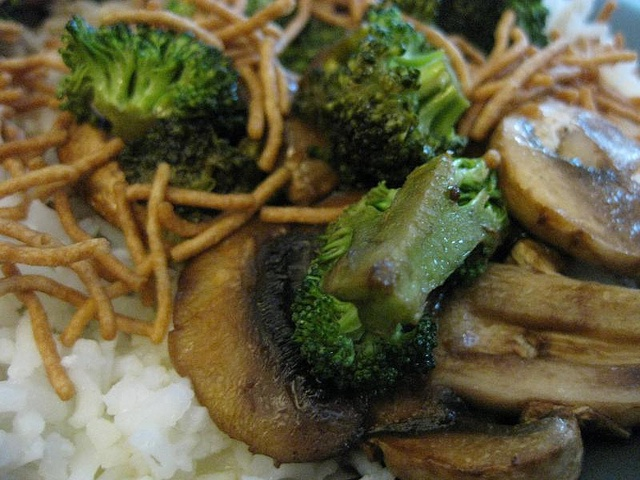Describe the objects in this image and their specific colors. I can see broccoli in gray, black, darkgreen, and green tones, broccoli in gray, black, darkgreen, and olive tones, broccoli in gray, darkgreen, black, and green tones, broccoli in gray, black, darkgreen, and teal tones, and broccoli in gray, black, and darkgreen tones in this image. 